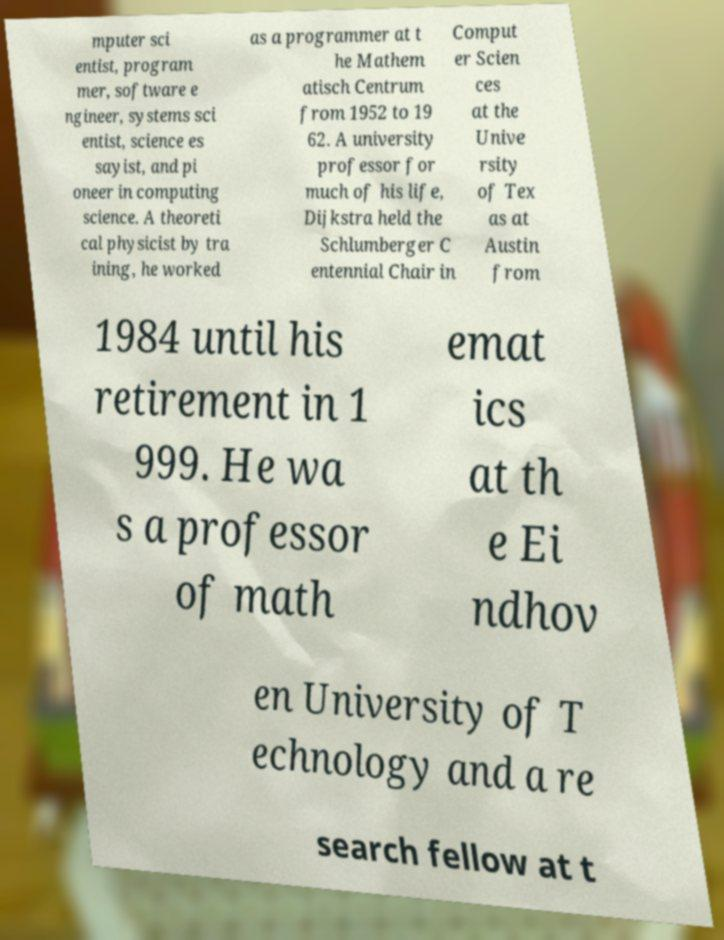I need the written content from this picture converted into text. Can you do that? mputer sci entist, program mer, software e ngineer, systems sci entist, science es sayist, and pi oneer in computing science. A theoreti cal physicist by tra ining, he worked as a programmer at t he Mathem atisch Centrum from 1952 to 19 62. A university professor for much of his life, Dijkstra held the Schlumberger C entennial Chair in Comput er Scien ces at the Unive rsity of Tex as at Austin from 1984 until his retirement in 1 999. He wa s a professor of math emat ics at th e Ei ndhov en University of T echnology and a re search fellow at t 